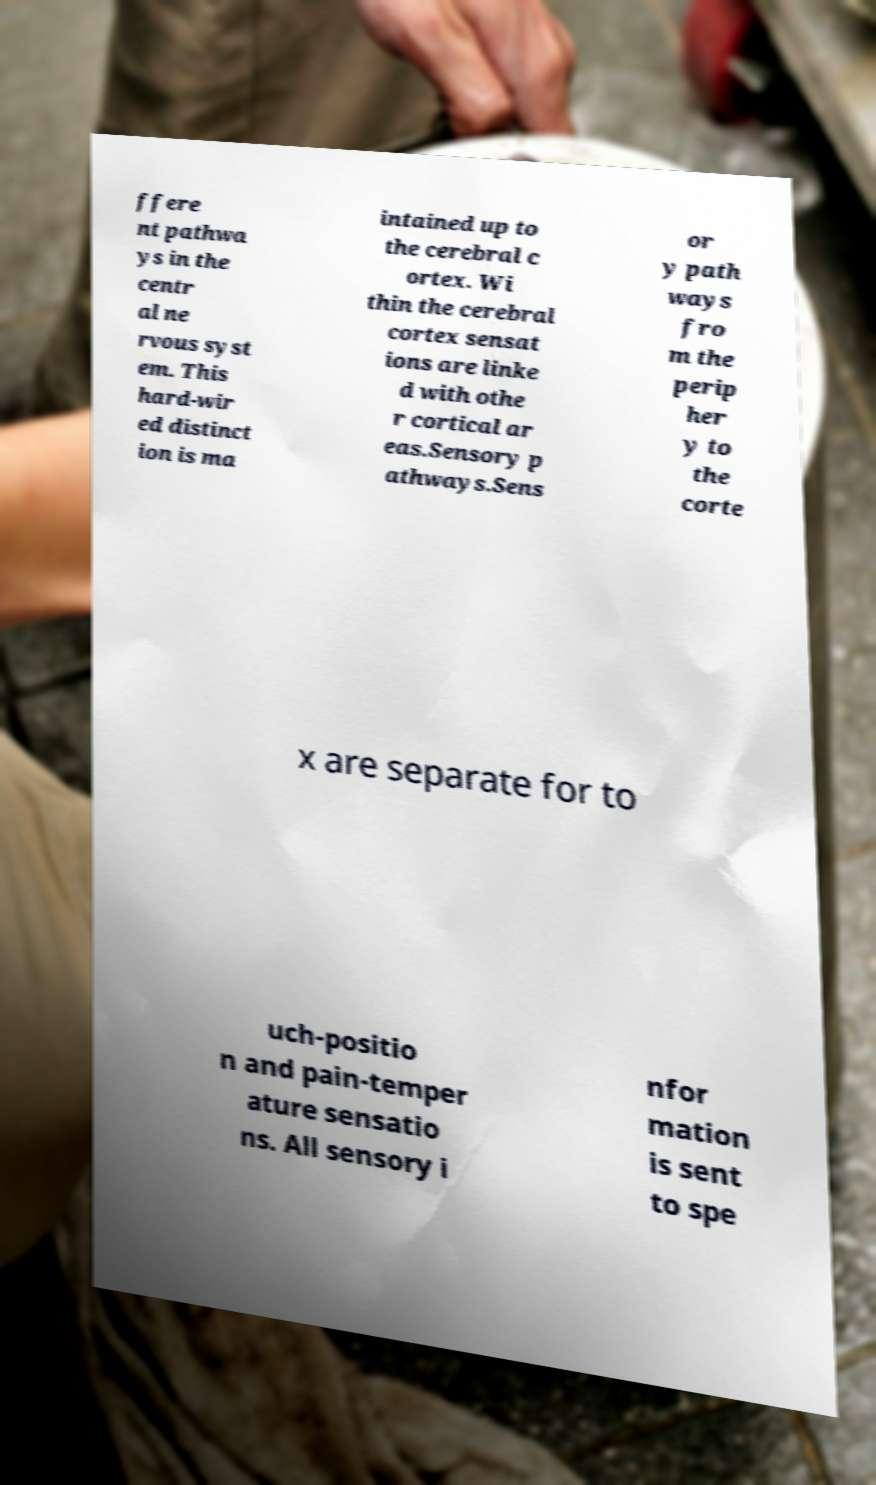For documentation purposes, I need the text within this image transcribed. Could you provide that? ffere nt pathwa ys in the centr al ne rvous syst em. This hard-wir ed distinct ion is ma intained up to the cerebral c ortex. Wi thin the cerebral cortex sensat ions are linke d with othe r cortical ar eas.Sensory p athways.Sens or y path ways fro m the perip her y to the corte x are separate for to uch-positio n and pain-temper ature sensatio ns. All sensory i nfor mation is sent to spe 